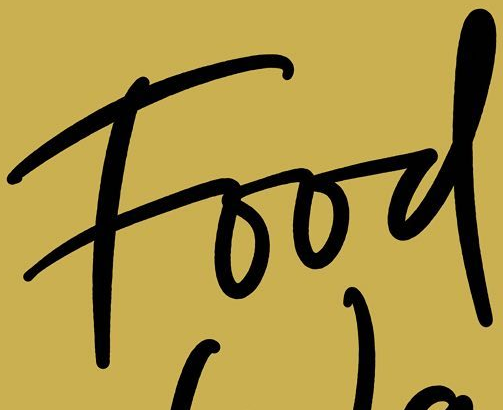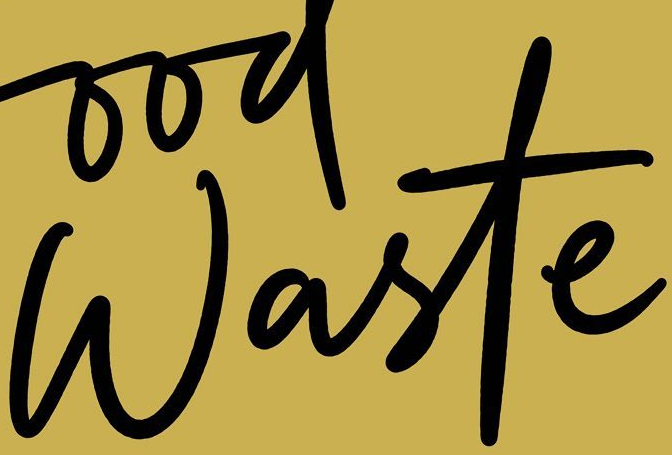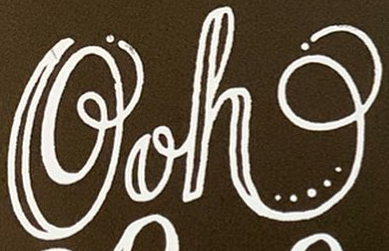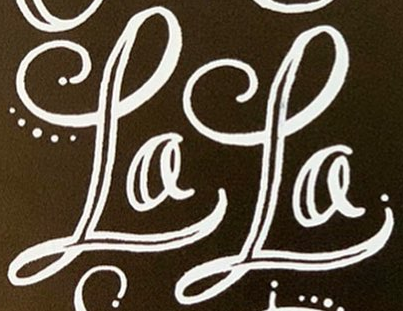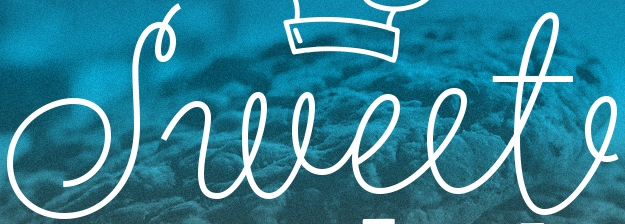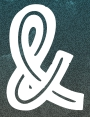What text is displayed in these images sequentially, separated by a semicolon? Food; Waste; Ooh; LaLa; Sweet; & 